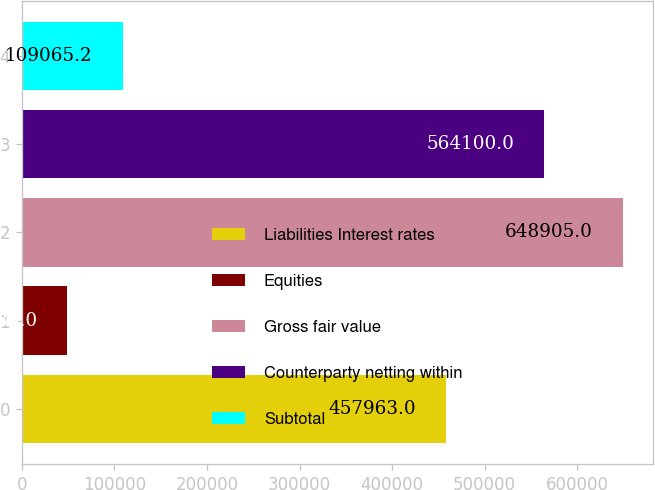Convert chart to OTSL. <chart><loc_0><loc_0><loc_500><loc_500><bar_chart><fcel>Liabilities Interest rates<fcel>Equities<fcel>Gross fair value<fcel>Counterparty netting within<fcel>Subtotal<nl><fcel>457963<fcel>49083<fcel>648905<fcel>564100<fcel>109065<nl></chart> 